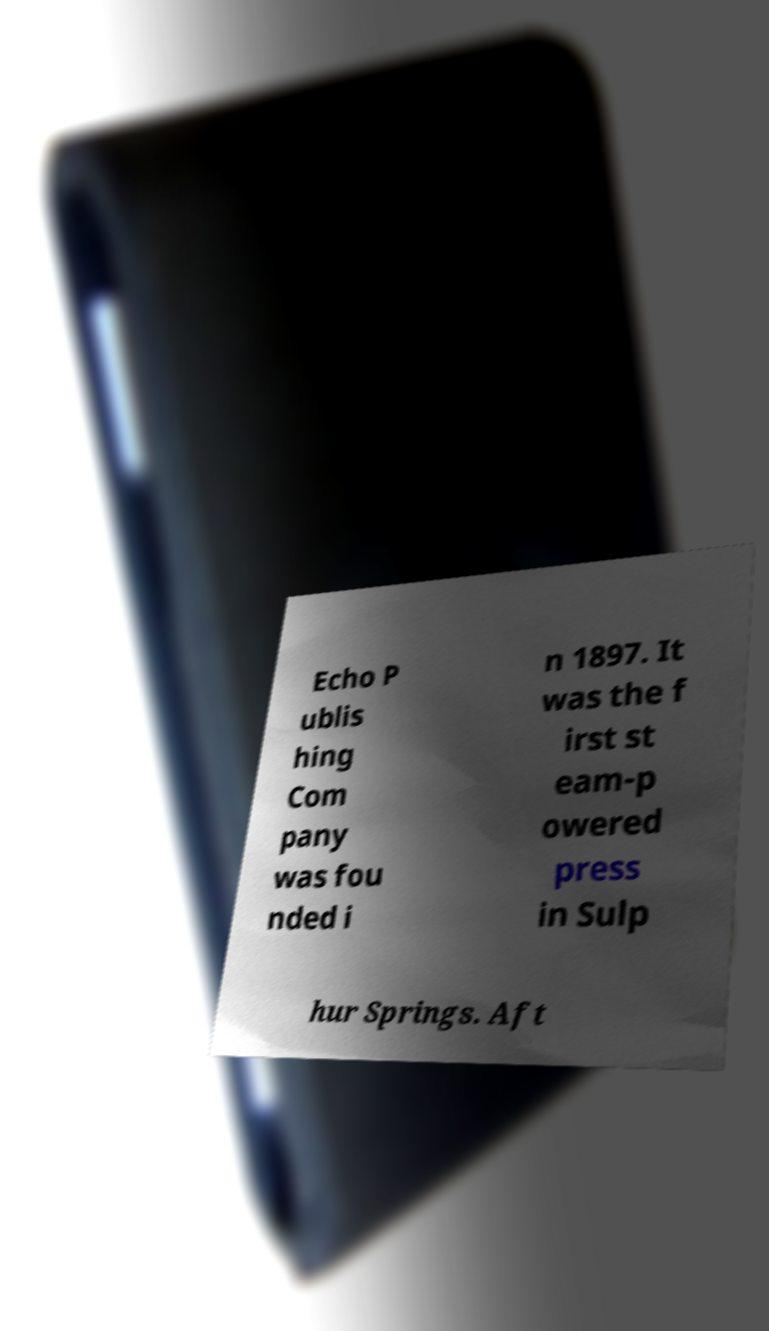Can you accurately transcribe the text from the provided image for me? Echo P ublis hing Com pany was fou nded i n 1897. It was the f irst st eam-p owered press in Sulp hur Springs. Aft 